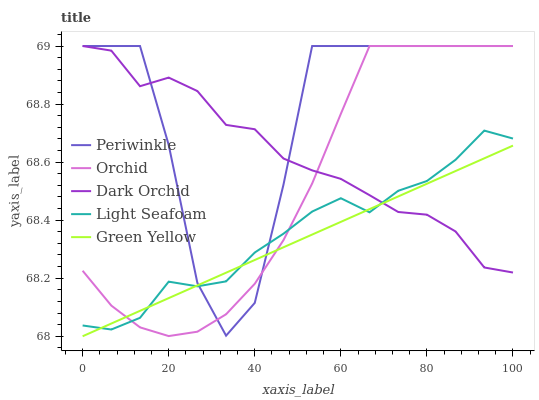Does Green Yellow have the minimum area under the curve?
Answer yes or no. Yes. Does Periwinkle have the maximum area under the curve?
Answer yes or no. Yes. Does Light Seafoam have the minimum area under the curve?
Answer yes or no. No. Does Light Seafoam have the maximum area under the curve?
Answer yes or no. No. Is Green Yellow the smoothest?
Answer yes or no. Yes. Is Periwinkle the roughest?
Answer yes or no. Yes. Is Light Seafoam the smoothest?
Answer yes or no. No. Is Light Seafoam the roughest?
Answer yes or no. No. Does Green Yellow have the lowest value?
Answer yes or no. Yes. Does Light Seafoam have the lowest value?
Answer yes or no. No. Does Orchid have the highest value?
Answer yes or no. Yes. Does Light Seafoam have the highest value?
Answer yes or no. No. Does Orchid intersect Periwinkle?
Answer yes or no. Yes. Is Orchid less than Periwinkle?
Answer yes or no. No. Is Orchid greater than Periwinkle?
Answer yes or no. No. 